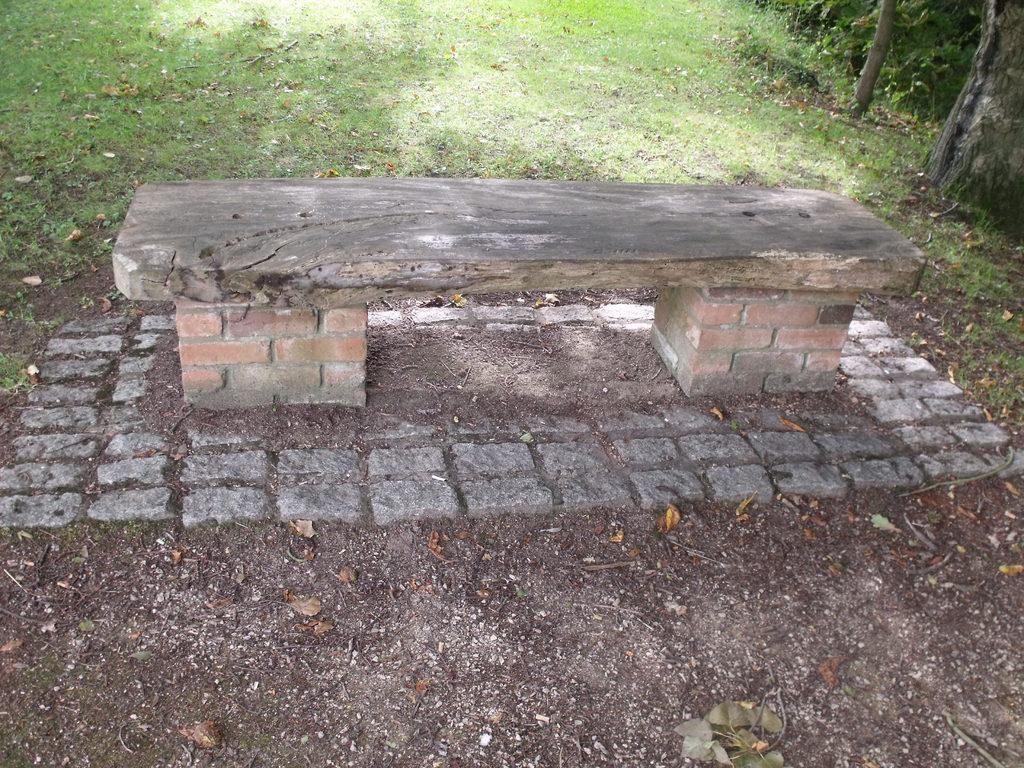What material is the plank in the image made of? The wooden plank in the image is made of wood. Where is the wooden plank located? The wooden plank is on brick walls. What type of vegetation is on the right side of the image? There are trees on the right side of the image. What can be seen at the top of the image? There is grass visible at the top of the image. What type of letter is being sent by the goldfish in the image? There is no goldfish present in the image, so it is not possible to answer that question. 